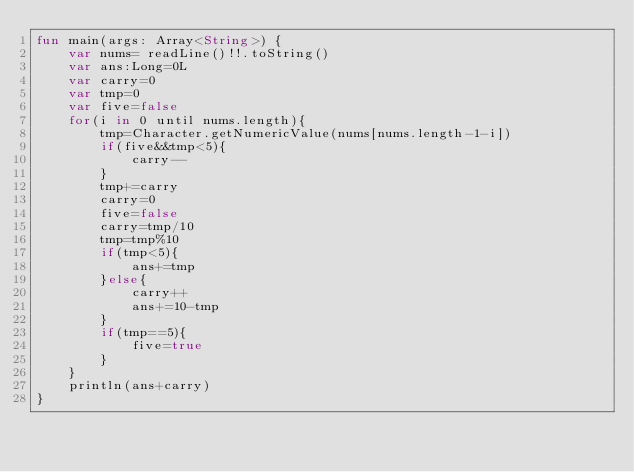Convert code to text. <code><loc_0><loc_0><loc_500><loc_500><_Kotlin_>fun main(args: Array<String>) {
    var nums= readLine()!!.toString()
    var ans:Long=0L
    var carry=0
    var tmp=0
    var five=false
    for(i in 0 until nums.length){
        tmp=Character.getNumericValue(nums[nums.length-1-i])
        if(five&&tmp<5){
            carry--
        }
        tmp+=carry
        carry=0
        five=false
        carry=tmp/10
        tmp=tmp%10
        if(tmp<5){
            ans+=tmp
        }else{
            carry++
            ans+=10-tmp
        }
        if(tmp==5){
            five=true
        }
    }
    println(ans+carry)
}
</code> 